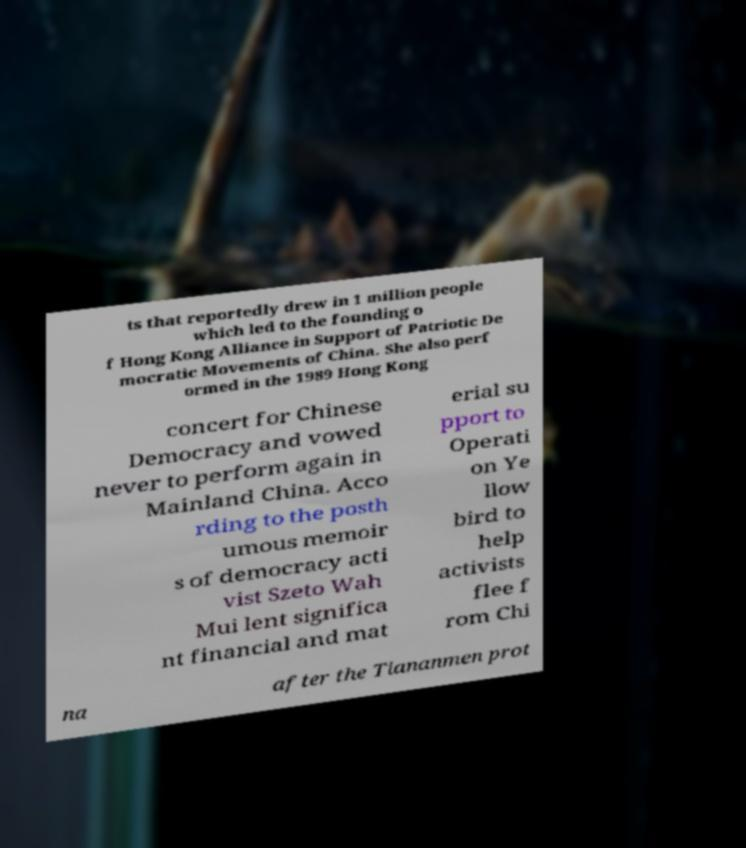Can you accurately transcribe the text from the provided image for me? ts that reportedly drew in 1 million people which led to the founding o f Hong Kong Alliance in Support of Patriotic De mocratic Movements of China. She also perf ormed in the 1989 Hong Kong concert for Chinese Democracy and vowed never to perform again in Mainland China. Acco rding to the posth umous memoir s of democracy acti vist Szeto Wah Mui lent significa nt financial and mat erial su pport to Operati on Ye llow bird to help activists flee f rom Chi na after the Tiananmen prot 